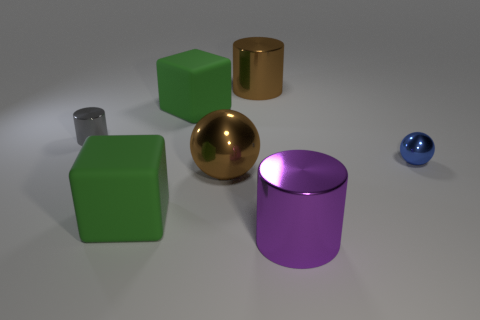What is the shape of the thing that is the same color as the large ball?
Offer a terse response. Cylinder. There is a gray thing; is it the same size as the brown object in front of the blue thing?
Offer a terse response. No. What number of small blue cylinders have the same material as the big brown ball?
Offer a terse response. 0. Is the size of the gray object the same as the purple metallic cylinder?
Keep it short and to the point. No. Is there anything else that is the same color as the big shiny ball?
Ensure brevity in your answer.  Yes. What shape is the big thing that is behind the tiny gray metallic cylinder and on the left side of the large brown sphere?
Your response must be concise. Cube. How big is the purple shiny cylinder that is to the right of the gray shiny object?
Keep it short and to the point. Large. There is a tiny object to the left of the shiny thing right of the big purple cylinder; how many tiny shiny objects are in front of it?
Make the answer very short. 1. There is a tiny gray metal cylinder; are there any small objects on the left side of it?
Offer a very short reply. No. What number of other things are the same size as the blue metal thing?
Make the answer very short. 1. 